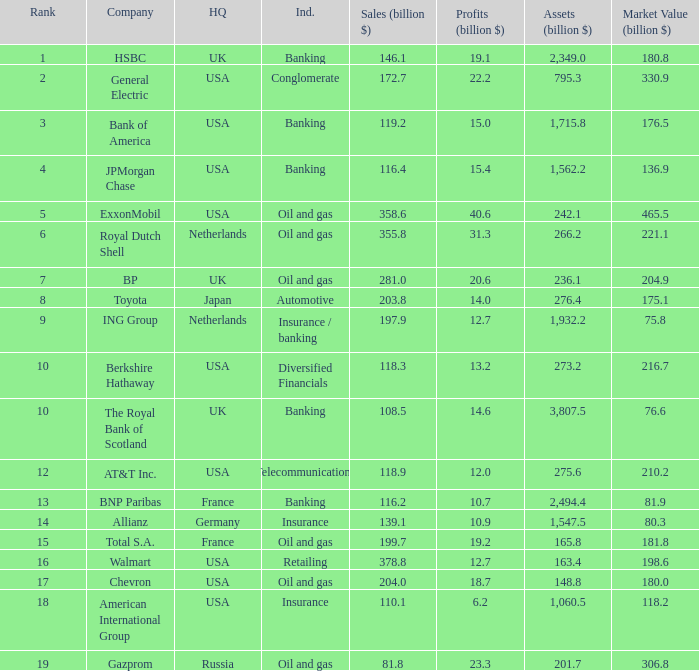What is the market value of a company in billions that has 172.7 billion in sales?  330.9. 